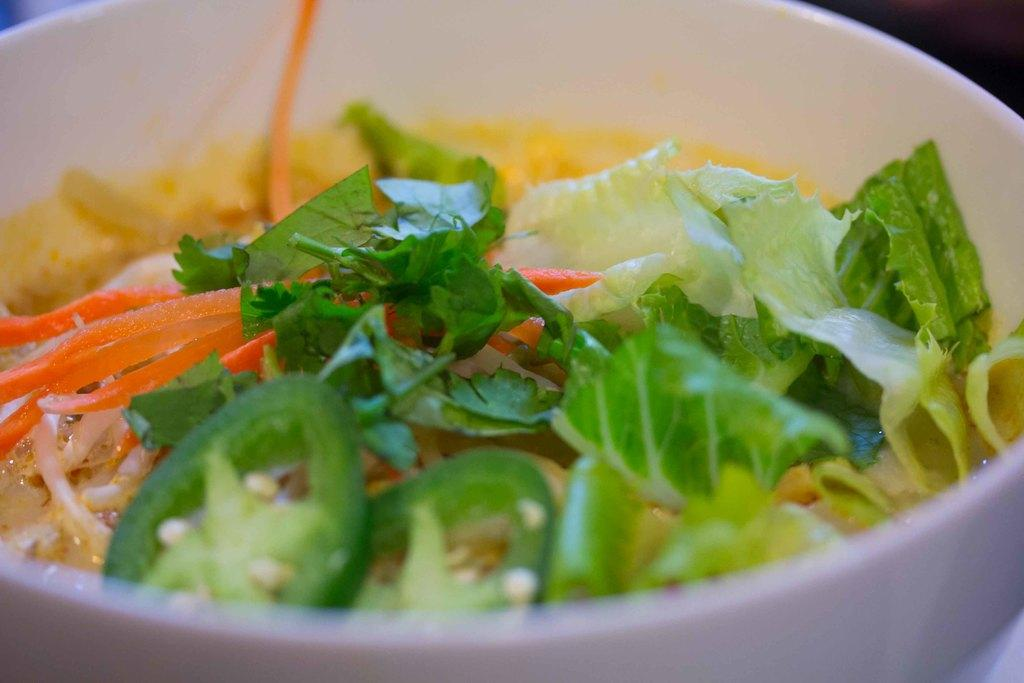What is in the bowl that is visible in the image? There is food in the bowl in the image. What specific ingredients can be found in the food? The food contains onions, carrots, jalapeno, parsley, cabbage, and lettuce. What message is conveyed by the good-bye sign in the image? There is no good-bye sign present in the image. 